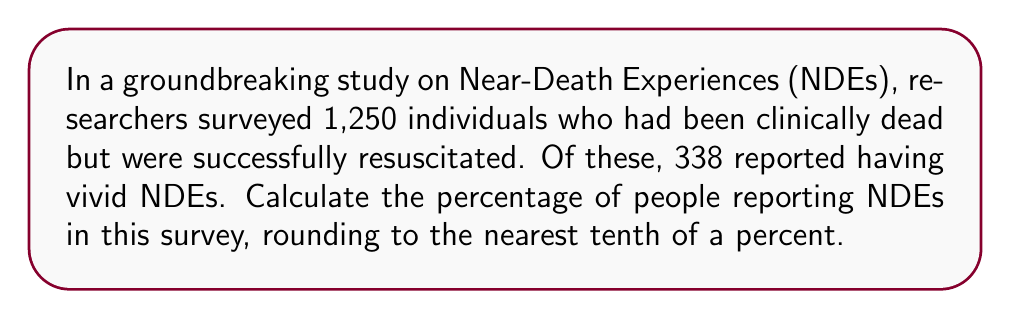Show me your answer to this math problem. To calculate the percentage of people reporting NDEs, we need to follow these steps:

1. Identify the total number of people surveyed:
   Total surveyed = 1,250

2. Identify the number of people reporting NDEs:
   People with NDEs = 338

3. Use the formula for percentage:
   $$ \text{Percentage} = \frac{\text{Number of people with NDEs}}{\text{Total number surveyed}} \times 100\% $$

4. Plug in the values:
   $$ \text{Percentage} = \frac{338}{1,250} \times 100\% $$

5. Perform the division:
   $$ \text{Percentage} = 0.2704 \times 100\% = 27.04\% $$

6. Round to the nearest tenth of a percent:
   27.04% rounds to 27.0%

Therefore, the percentage of people reporting NDEs in this survey is 27.0%.
Answer: 27.0% 